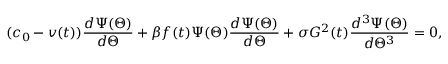Convert formula to latex. <formula><loc_0><loc_0><loc_500><loc_500>( c _ { 0 } - v ( t ) ) \frac { d \Psi ( \Theta ) } { d \Theta } + \beta f ( t ) \Psi ( \Theta ) \frac { d \Psi ( \Theta ) } { d \Theta } + \sigma G ^ { 2 } ( t ) \frac { d ^ { 3 } \Psi ( \Theta ) } { d \Theta ^ { 3 } } = 0 ,</formula> 